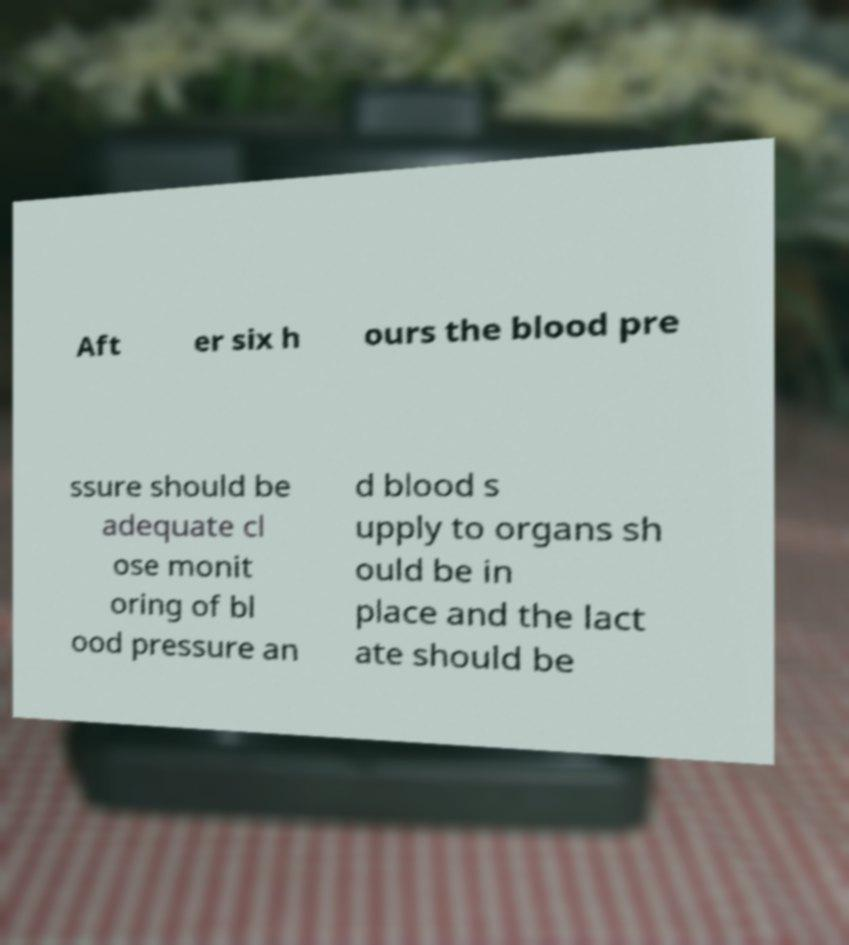Can you read and provide the text displayed in the image?This photo seems to have some interesting text. Can you extract and type it out for me? Aft er six h ours the blood pre ssure should be adequate cl ose monit oring of bl ood pressure an d blood s upply to organs sh ould be in place and the lact ate should be 